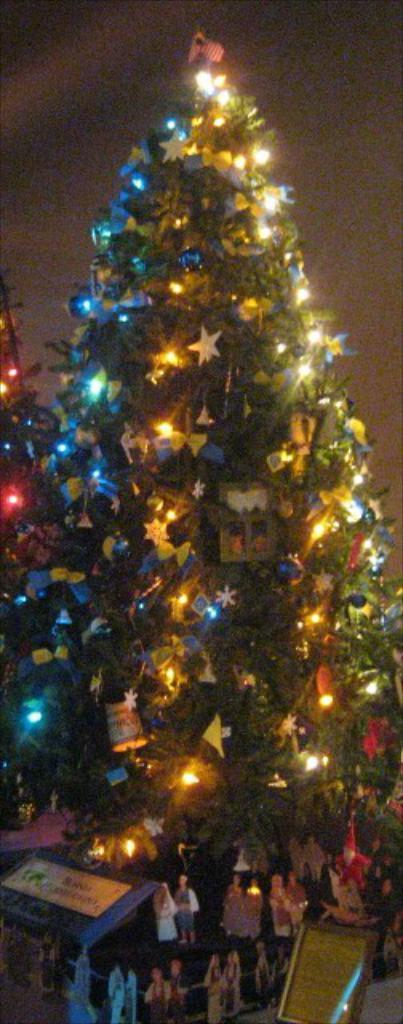What is the main subject of the image? There is a decorated Christmas tree in the image. Are there any other objects or figures near the Christmas tree? Yes, there are statues of people under the Christmas tree. Where are the statues placed? The statues are placed on a table. Can you see any clovers growing around the Christmas tree in the image? No, there are no clovers visible in the image. 